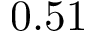Convert formula to latex. <formula><loc_0><loc_0><loc_500><loc_500>0 . 5 1</formula> 